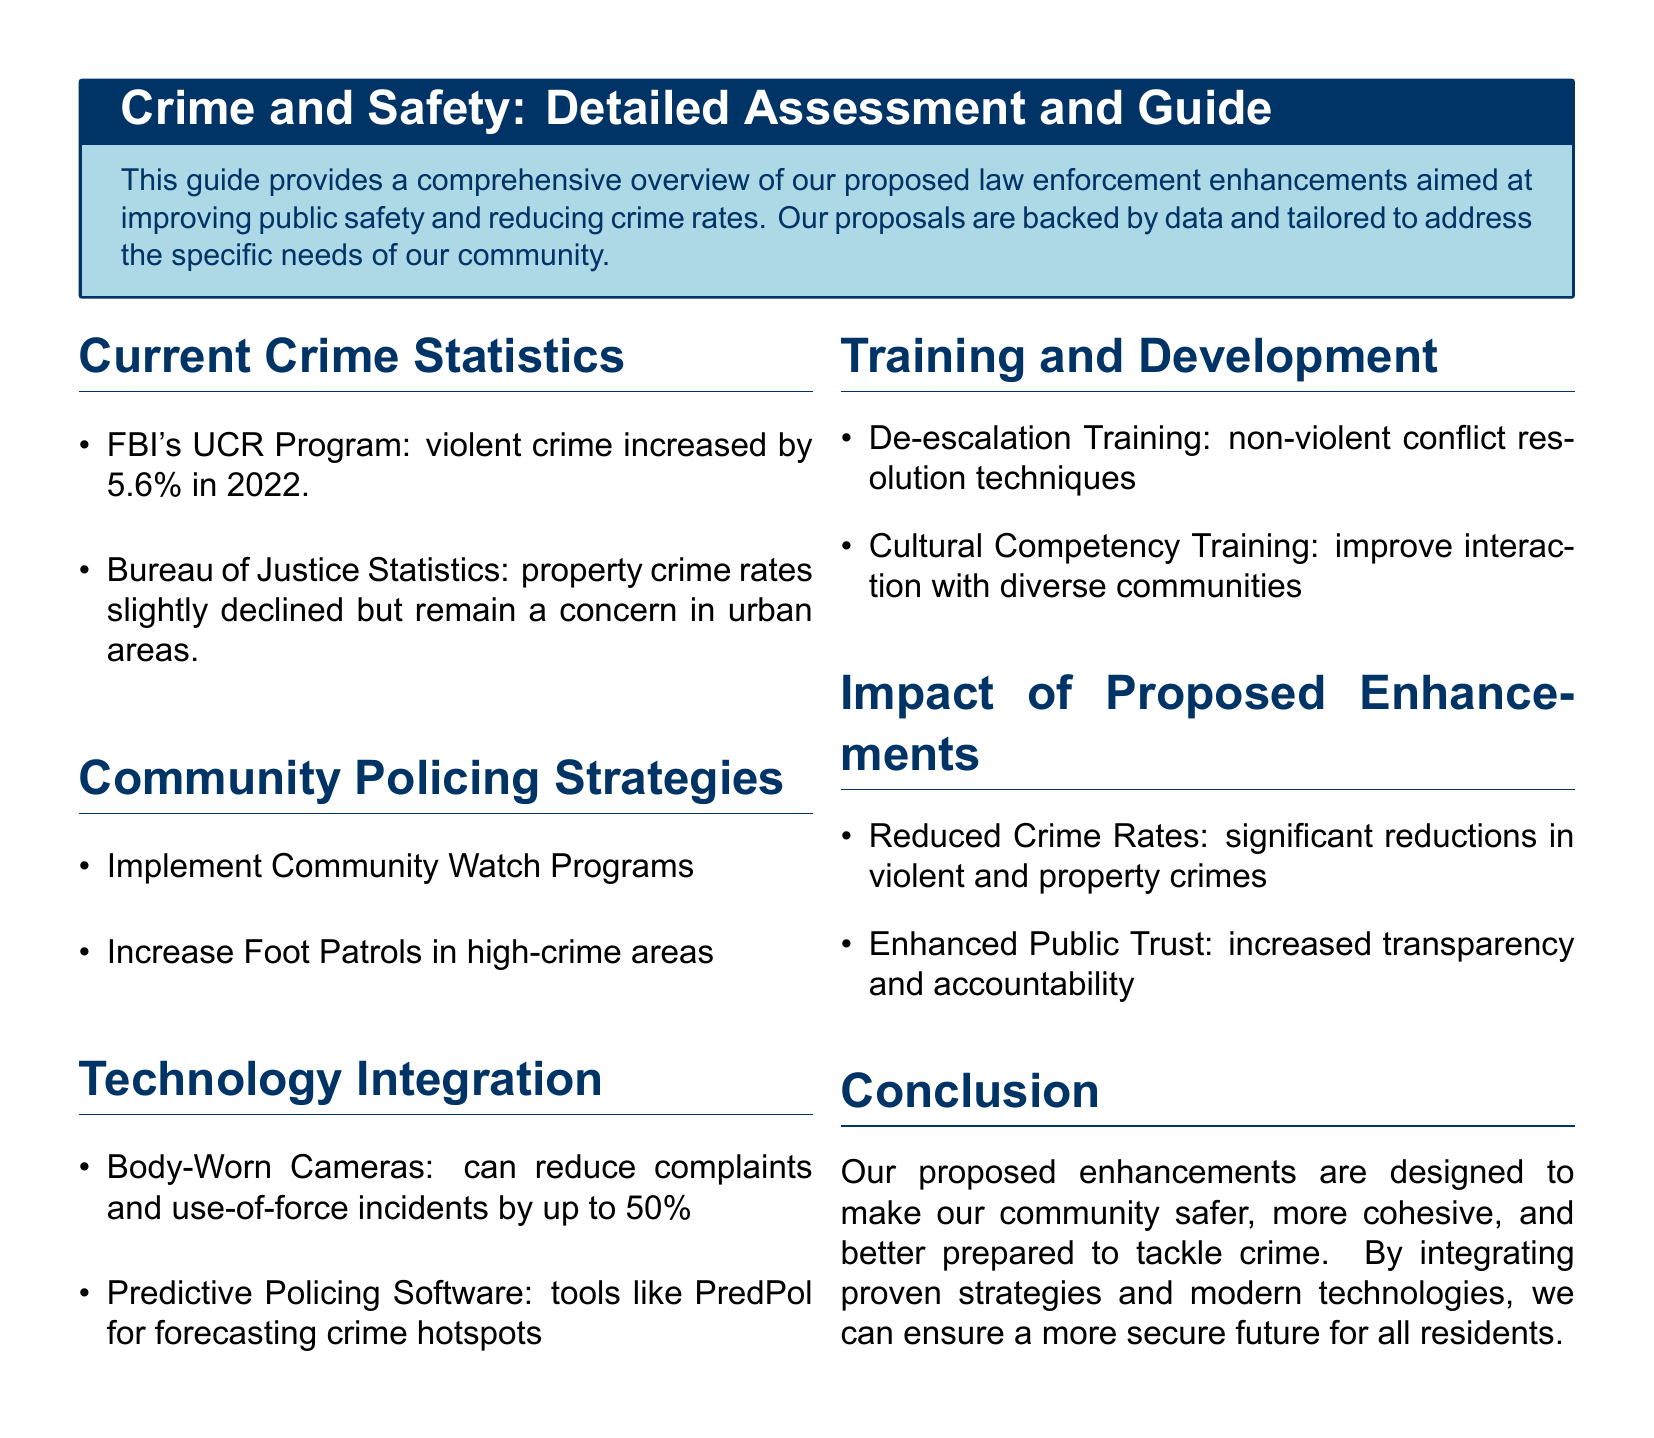what was the increase in violent crime in 2022? The document states that the violent crime increased by 5.6% in 2022 according to the FBI's UCR Program.
Answer: 5.6% what technology can reduce use-of-force incidents? The document mentions body-worn cameras can reduce complaints and use-of-force incidents by up to 50%.
Answer: body-worn cameras what is a proposed strategy for community safety? One of the proposed strategies includes implementing Community Watch Programs.
Answer: Community Watch Programs what training focuses on non-violent conflict resolution? The document identifies de-escalation training as focusing on non-violent conflict resolution techniques.
Answer: de-escalation training how can technology enhance policing? The document discusses predictive policing software, such as PredPol, for forecasting crime hotspots.
Answer: predictive policing software what is the anticipated impact of the proposed enhancements on public trust? The document asserts that the proposed enhancements aim to increase transparency and accountability, enhancing public trust.
Answer: increased transparency and accountability 